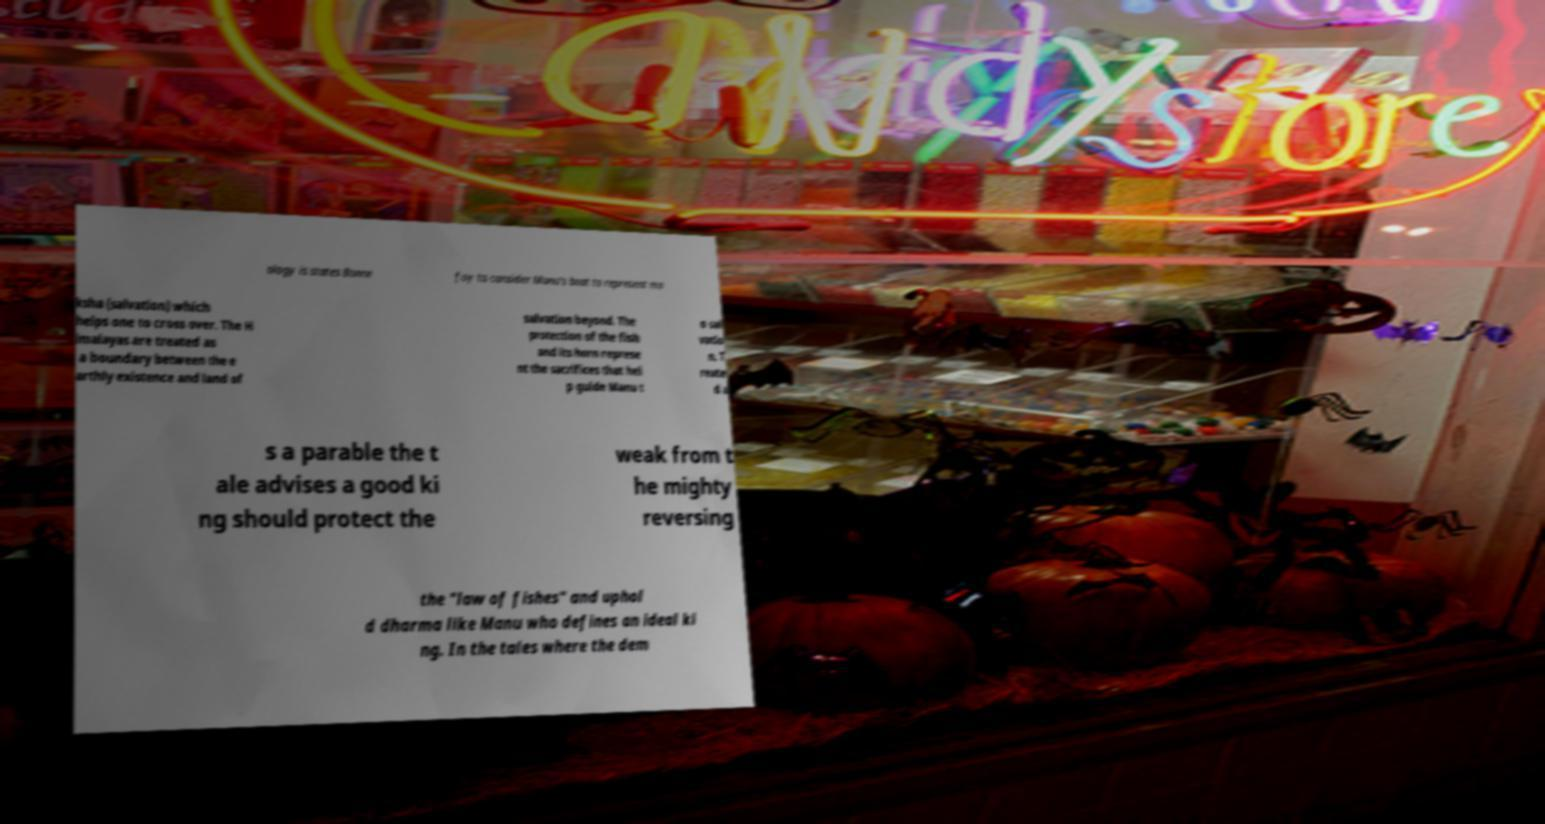For documentation purposes, I need the text within this image transcribed. Could you provide that? ology is states Bonne foy to consider Manu's boat to represent mo ksha (salvation) which helps one to cross over. The H imalayas are treated as a boundary between the e arthly existence and land of salvation beyond. The protection of the fish and its horn represe nt the sacrifices that hel p guide Manu t o sal vatio n. T reate d a s a parable the t ale advises a good ki ng should protect the weak from t he mighty reversing the "law of fishes" and uphol d dharma like Manu who defines an ideal ki ng. In the tales where the dem 